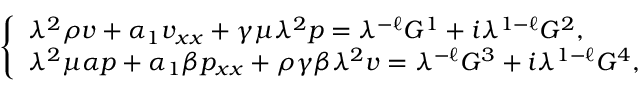<formula> <loc_0><loc_0><loc_500><loc_500>\left \{ \begin{array} { l } { { \lambda } ^ { 2 } \rho v + \alpha _ { 1 } v _ { x x } + \gamma \mu { \lambda } ^ { 2 } p = { \lambda } ^ { - \ell } G ^ { 1 } + i { \lambda } ^ { 1 - \ell } G ^ { 2 } , } \\ { { \lambda } ^ { 2 } \mu \alpha p + \alpha _ { 1 } \beta p _ { x x } + \rho \gamma \beta { \lambda } ^ { 2 } v = { \lambda } ^ { - \ell } G ^ { 3 } + i { \lambda } ^ { 1 - \ell } G ^ { 4 } , } \end{array}</formula> 